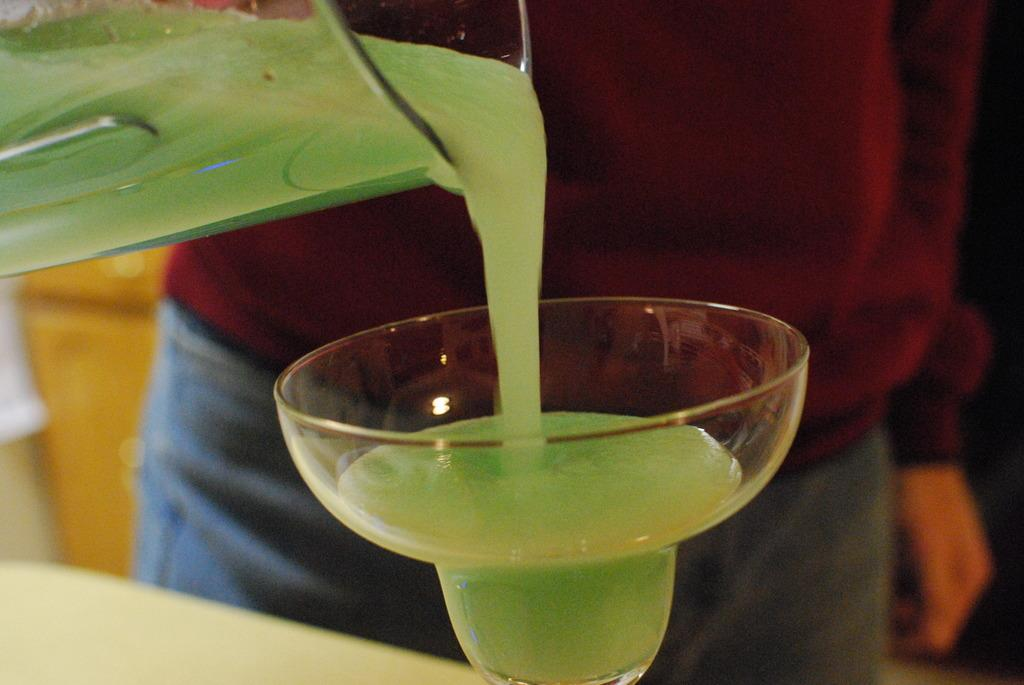What is the main subject of the image? There is a person standing in the center of the image. What is the person holding in the image? The person is holding a mug. What action is the person performing in the image? The person is pouring a liquid into a cup. What is present at the bottom of the image? There is a table at the bottom of the image. What object is on the table in the image? There is a cup on the table. What type of vegetable is being used as bait in the image? There is no vegetable or bait present in the image; it features a person pouring a liquid into a cup. Is there a plane visible in the image? No, there is no plane present in the image. 